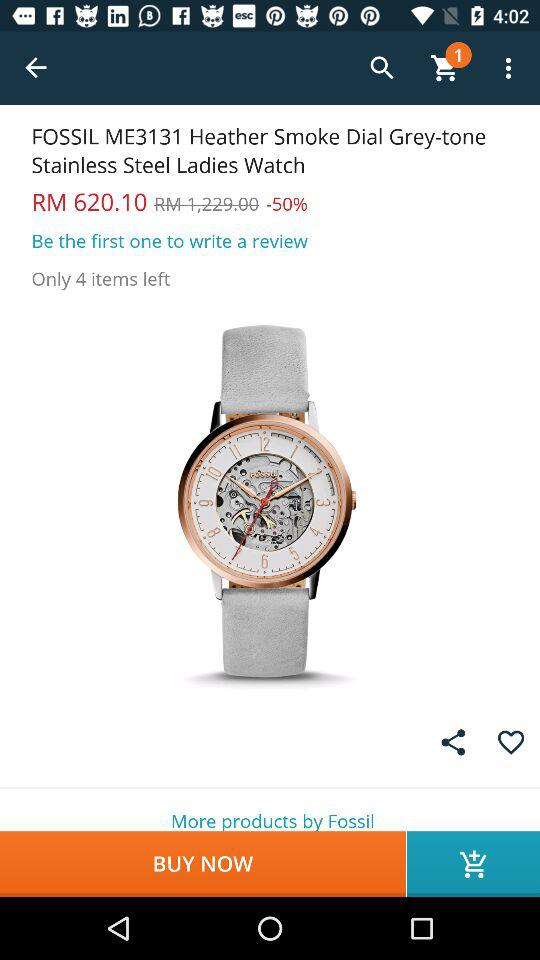How many items are left in stock?
Answer the question using a single word or phrase. 4 